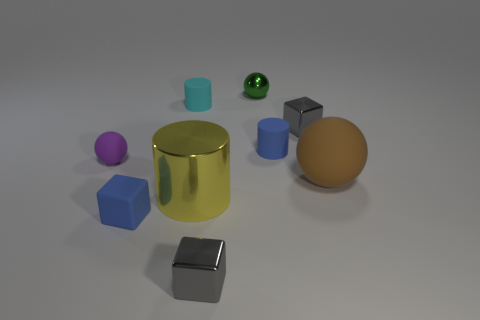Is the color of the shiny cylinder the same as the tiny shiny ball?
Give a very brief answer. No. There is a small blue thing that is behind the ball that is right of the green shiny thing; what is its shape?
Ensure brevity in your answer.  Cylinder. Is the number of shiny objects less than the number of purple rubber objects?
Make the answer very short. No. There is a matte object that is behind the big brown object and on the right side of the large shiny cylinder; what size is it?
Offer a very short reply. Small. Is the blue matte block the same size as the metallic cylinder?
Provide a succinct answer. No. There is a small rubber cylinder right of the small cyan object; is it the same color as the matte block?
Your response must be concise. Yes. What number of large metal cylinders are to the left of the big yellow thing?
Make the answer very short. 0. Is the number of tiny blue matte objects greater than the number of tiny green rubber blocks?
Your answer should be compact. Yes. There is a rubber thing that is both on the right side of the tiny green metallic thing and left of the brown rubber thing; what shape is it?
Ensure brevity in your answer.  Cylinder. Are any big cylinders visible?
Offer a very short reply. Yes. 